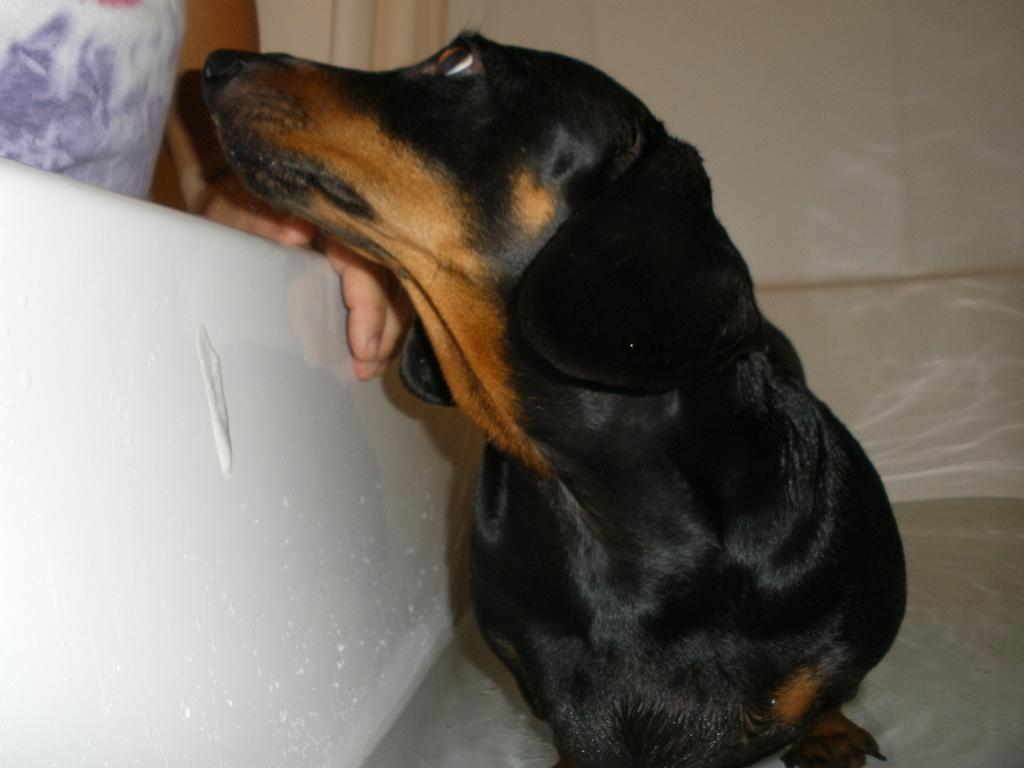What is the main subject in the center of the image? There is a dog in the center of the image. Can you describe the appearance of the dog? The dog is black and brown in color. Where is the person located in the image? The person is on the left top of the image. What can be seen in the background of the image? There is a wall in the background of the image. How many rings does the dog have on its lip in the image? There are no rings or lips present on the dog in the image. 